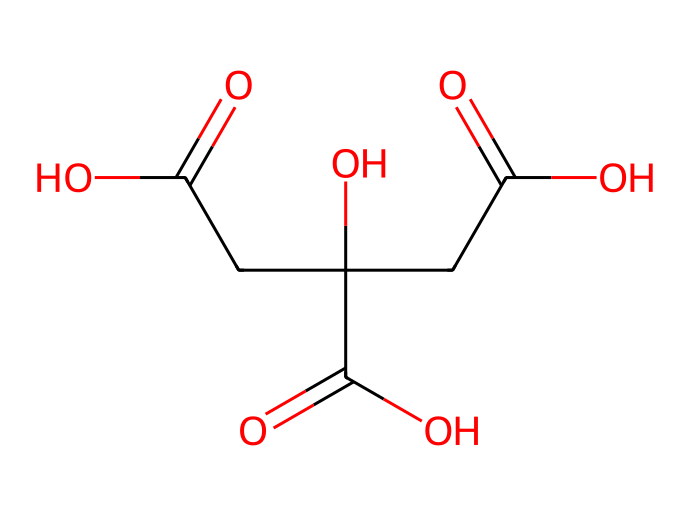What is the molecular formula of this chemical? The SMILES representation indicates the presence of carbon (C), hydrogen (H), and oxygen (O) atoms. By counting the symbols in the structure, we find that there are 6 carbon atoms, 8 hydrogen atoms, and 7 oxygen atoms, leading to the molecular formula C6H8O7.
Answer: C6H8O7 How many carboxylic acid groups are present in this structure? By analyzing the SMILES representation, we can identify the functional groups present. The carboxylic acid group is indicated by the presence of -COOH units in the chemical structure. We can see three instances of this group in the SMILES notation.
Answer: 3 Is this chemical a solid, liquid, or gas at room temperature? Citric acid is known to be a solid at room temperature. Thus, it has a crystalline structure that forms a solid-state at typical temperatures encountered in everyday conditions.
Answer: solid What type of food additive is citric acid classified as? Citric acid is commonly used as a preservative and flavoring agent in food products. It helps in maintaining the pH levels and acts as a natural preservative, classifying it as an acidulant in the context of food additives.
Answer: acidulant Which functional group indicates the acidity of citric acid? The presence of the carboxylic acid functional groups (-COOH) in the structure is what gives citric acid its acidic properties. Each of these groups can donate a hydrogen ion (H+), contributing to its acidity.
Answer: carboxylic acid What role does citric acid play in sports drinks? Citric acid helps in enhancing flavor and preserving the stability of the drinks. Its acidic nature also assists in balancing electrolytes, making it beneficial for hydration during sports activities.
Answer: flavoring and preservation 